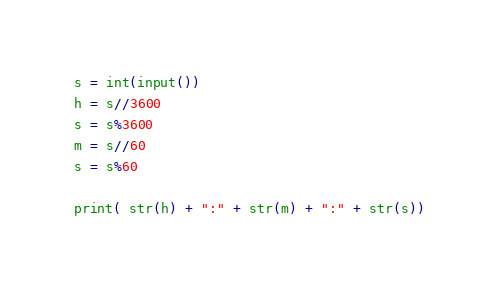<code> <loc_0><loc_0><loc_500><loc_500><_Python_>s = int(input())
h = s//3600
s = s%3600
m = s//60
s = s%60

print( str(h) + ":" + str(m) + ":" + str(s))
</code> 